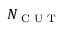Convert formula to latex. <formula><loc_0><loc_0><loc_500><loc_500>N _ { C U T }</formula> 